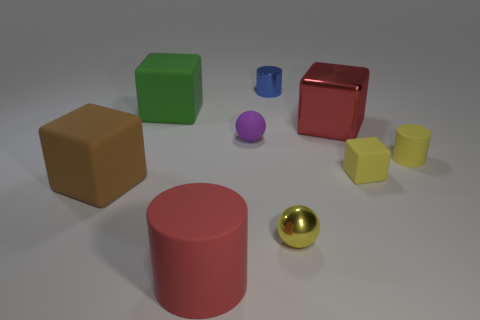Subtract all blocks. How many objects are left? 5 Add 8 small red objects. How many small red objects exist? 8 Subtract 0 green balls. How many objects are left? 9 Subtract all large things. Subtract all small cubes. How many objects are left? 4 Add 6 big green blocks. How many big green blocks are left? 7 